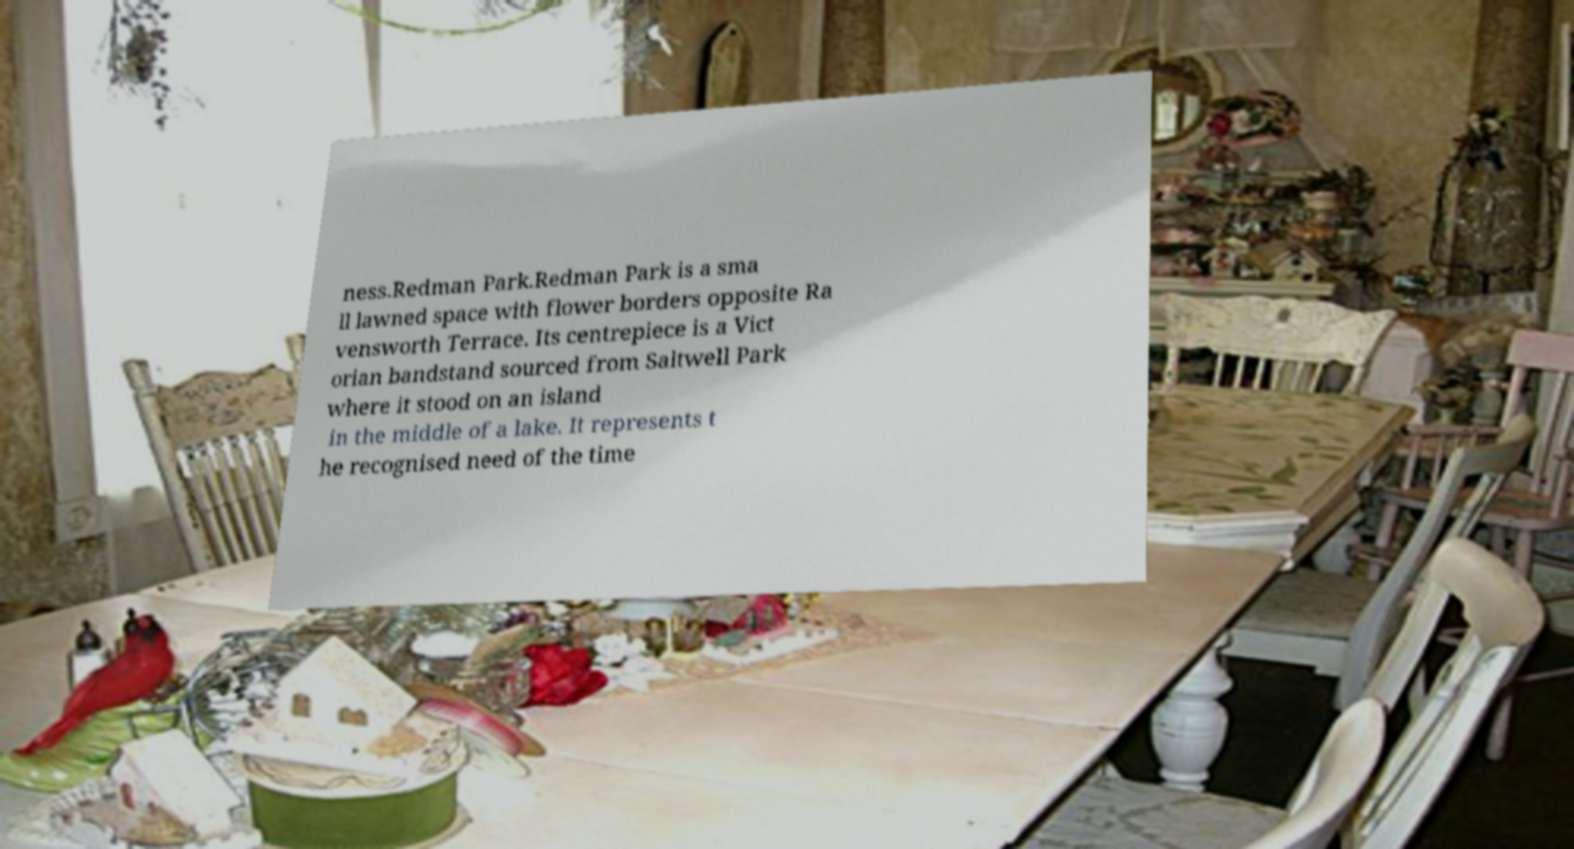For documentation purposes, I need the text within this image transcribed. Could you provide that? ness.Redman Park.Redman Park is a sma ll lawned space with flower borders opposite Ra vensworth Terrace. Its centrepiece is a Vict orian bandstand sourced from Saltwell Park where it stood on an island in the middle of a lake. It represents t he recognised need of the time 